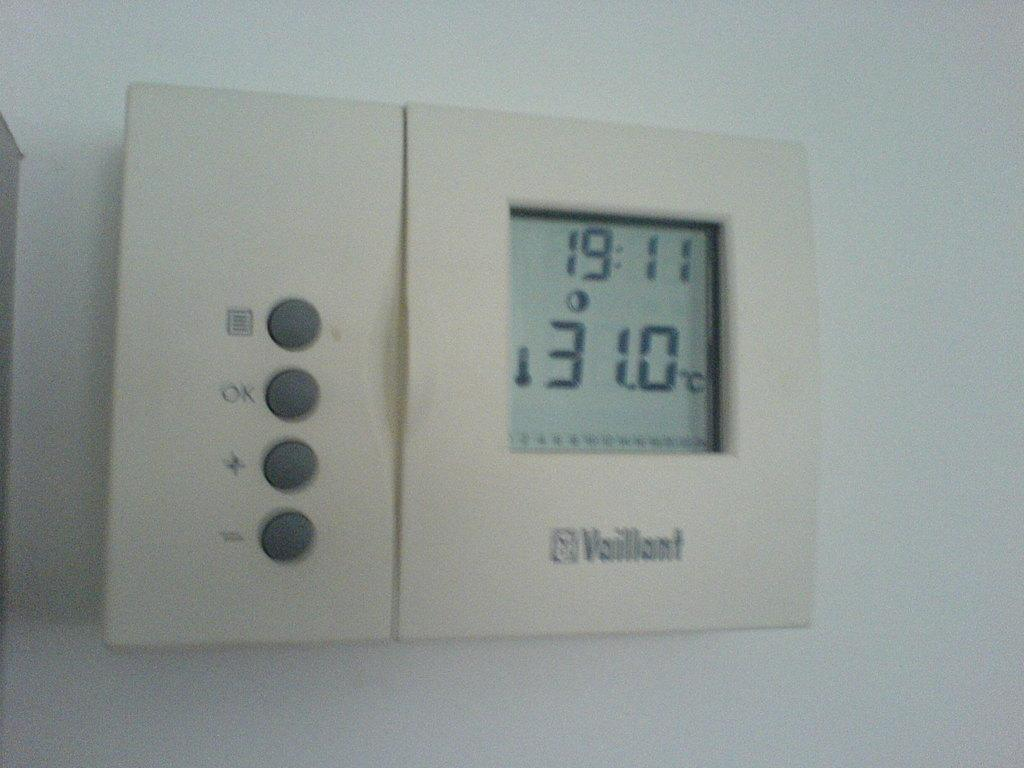Provide a one-sentence caption for the provided image. A Vaillant thermostat on the wall says 31.0 degrees. 